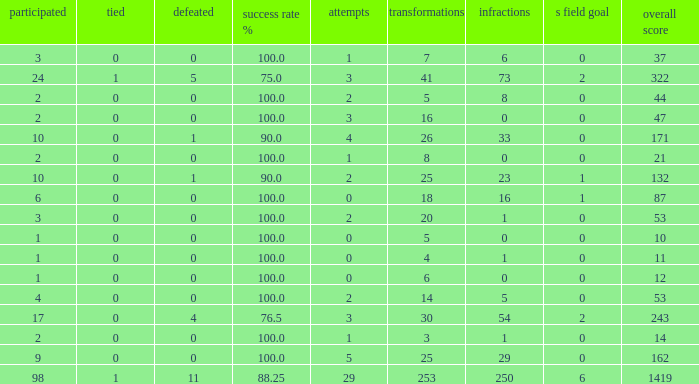How many ties did he have when he had 1 penalties and more than 20 conversions? None. 